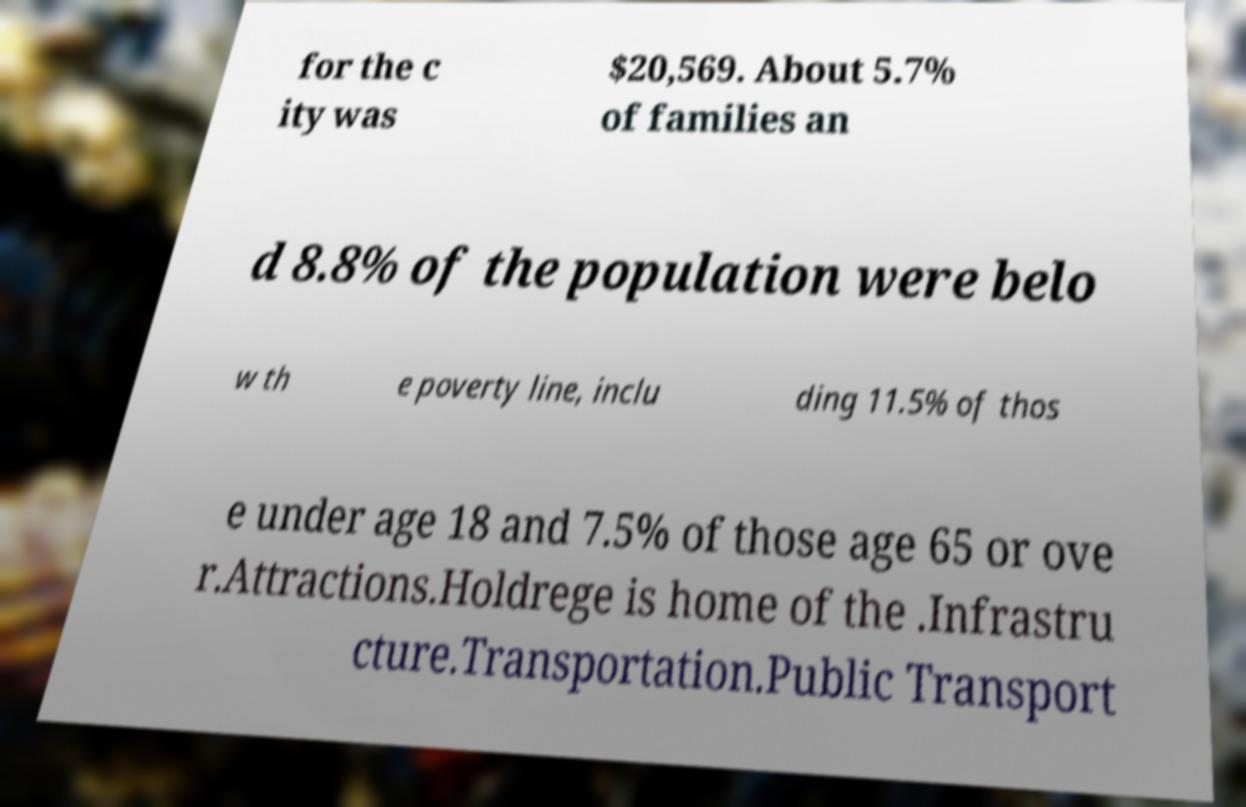Could you assist in decoding the text presented in this image and type it out clearly? for the c ity was $20,569. About 5.7% of families an d 8.8% of the population were belo w th e poverty line, inclu ding 11.5% of thos e under age 18 and 7.5% of those age 65 or ove r.Attractions.Holdrege is home of the .Infrastru cture.Transportation.Public Transport 